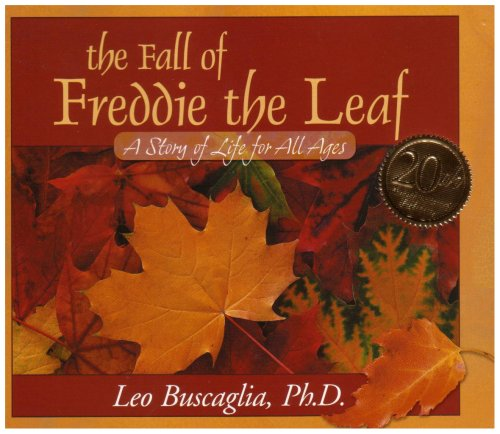Is this book related to Engineering & Transportation? No, this book is not related to Engineering & Transportation. It focuses on philosophical and existential themes, using the life cycle of a leaf as a metaphor to explore such topics. 